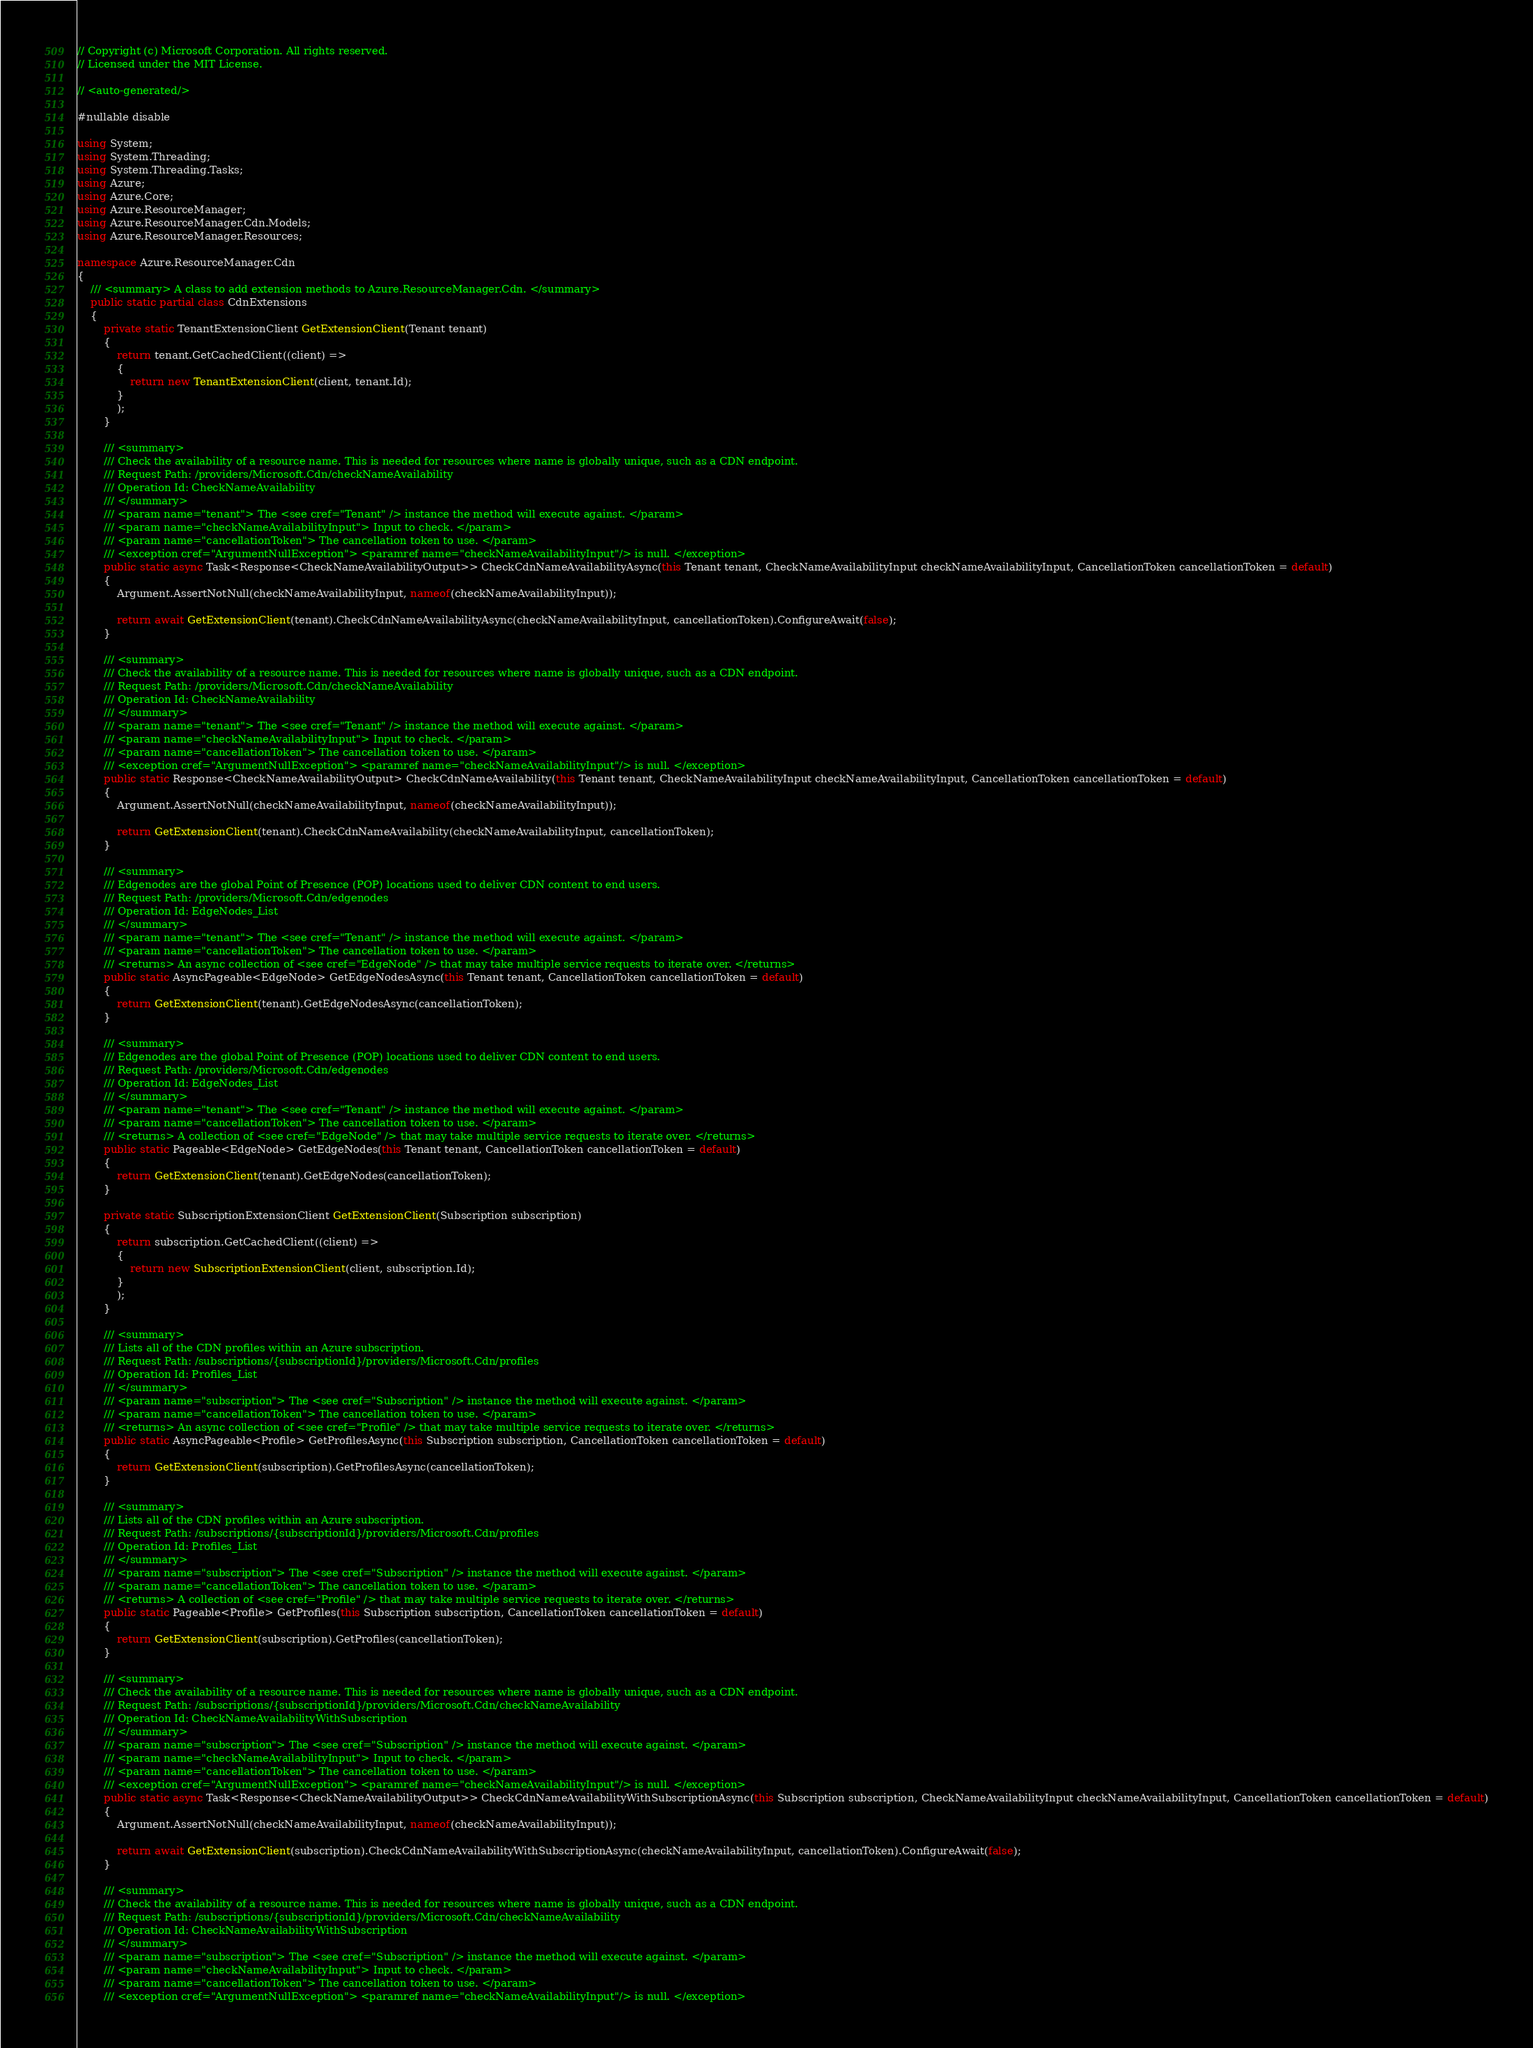<code> <loc_0><loc_0><loc_500><loc_500><_C#_>// Copyright (c) Microsoft Corporation. All rights reserved.
// Licensed under the MIT License.

// <auto-generated/>

#nullable disable

using System;
using System.Threading;
using System.Threading.Tasks;
using Azure;
using Azure.Core;
using Azure.ResourceManager;
using Azure.ResourceManager.Cdn.Models;
using Azure.ResourceManager.Resources;

namespace Azure.ResourceManager.Cdn
{
    /// <summary> A class to add extension methods to Azure.ResourceManager.Cdn. </summary>
    public static partial class CdnExtensions
    {
        private static TenantExtensionClient GetExtensionClient(Tenant tenant)
        {
            return tenant.GetCachedClient((client) =>
            {
                return new TenantExtensionClient(client, tenant.Id);
            }
            );
        }

        /// <summary>
        /// Check the availability of a resource name. This is needed for resources where name is globally unique, such as a CDN endpoint.
        /// Request Path: /providers/Microsoft.Cdn/checkNameAvailability
        /// Operation Id: CheckNameAvailability
        /// </summary>
        /// <param name="tenant"> The <see cref="Tenant" /> instance the method will execute against. </param>
        /// <param name="checkNameAvailabilityInput"> Input to check. </param>
        /// <param name="cancellationToken"> The cancellation token to use. </param>
        /// <exception cref="ArgumentNullException"> <paramref name="checkNameAvailabilityInput"/> is null. </exception>
        public static async Task<Response<CheckNameAvailabilityOutput>> CheckCdnNameAvailabilityAsync(this Tenant tenant, CheckNameAvailabilityInput checkNameAvailabilityInput, CancellationToken cancellationToken = default)
        {
            Argument.AssertNotNull(checkNameAvailabilityInput, nameof(checkNameAvailabilityInput));

            return await GetExtensionClient(tenant).CheckCdnNameAvailabilityAsync(checkNameAvailabilityInput, cancellationToken).ConfigureAwait(false);
        }

        /// <summary>
        /// Check the availability of a resource name. This is needed for resources where name is globally unique, such as a CDN endpoint.
        /// Request Path: /providers/Microsoft.Cdn/checkNameAvailability
        /// Operation Id: CheckNameAvailability
        /// </summary>
        /// <param name="tenant"> The <see cref="Tenant" /> instance the method will execute against. </param>
        /// <param name="checkNameAvailabilityInput"> Input to check. </param>
        /// <param name="cancellationToken"> The cancellation token to use. </param>
        /// <exception cref="ArgumentNullException"> <paramref name="checkNameAvailabilityInput"/> is null. </exception>
        public static Response<CheckNameAvailabilityOutput> CheckCdnNameAvailability(this Tenant tenant, CheckNameAvailabilityInput checkNameAvailabilityInput, CancellationToken cancellationToken = default)
        {
            Argument.AssertNotNull(checkNameAvailabilityInput, nameof(checkNameAvailabilityInput));

            return GetExtensionClient(tenant).CheckCdnNameAvailability(checkNameAvailabilityInput, cancellationToken);
        }

        /// <summary>
        /// Edgenodes are the global Point of Presence (POP) locations used to deliver CDN content to end users.
        /// Request Path: /providers/Microsoft.Cdn/edgenodes
        /// Operation Id: EdgeNodes_List
        /// </summary>
        /// <param name="tenant"> The <see cref="Tenant" /> instance the method will execute against. </param>
        /// <param name="cancellationToken"> The cancellation token to use. </param>
        /// <returns> An async collection of <see cref="EdgeNode" /> that may take multiple service requests to iterate over. </returns>
        public static AsyncPageable<EdgeNode> GetEdgeNodesAsync(this Tenant tenant, CancellationToken cancellationToken = default)
        {
            return GetExtensionClient(tenant).GetEdgeNodesAsync(cancellationToken);
        }

        /// <summary>
        /// Edgenodes are the global Point of Presence (POP) locations used to deliver CDN content to end users.
        /// Request Path: /providers/Microsoft.Cdn/edgenodes
        /// Operation Id: EdgeNodes_List
        /// </summary>
        /// <param name="tenant"> The <see cref="Tenant" /> instance the method will execute against. </param>
        /// <param name="cancellationToken"> The cancellation token to use. </param>
        /// <returns> A collection of <see cref="EdgeNode" /> that may take multiple service requests to iterate over. </returns>
        public static Pageable<EdgeNode> GetEdgeNodes(this Tenant tenant, CancellationToken cancellationToken = default)
        {
            return GetExtensionClient(tenant).GetEdgeNodes(cancellationToken);
        }

        private static SubscriptionExtensionClient GetExtensionClient(Subscription subscription)
        {
            return subscription.GetCachedClient((client) =>
            {
                return new SubscriptionExtensionClient(client, subscription.Id);
            }
            );
        }

        /// <summary>
        /// Lists all of the CDN profiles within an Azure subscription.
        /// Request Path: /subscriptions/{subscriptionId}/providers/Microsoft.Cdn/profiles
        /// Operation Id: Profiles_List
        /// </summary>
        /// <param name="subscription"> The <see cref="Subscription" /> instance the method will execute against. </param>
        /// <param name="cancellationToken"> The cancellation token to use. </param>
        /// <returns> An async collection of <see cref="Profile" /> that may take multiple service requests to iterate over. </returns>
        public static AsyncPageable<Profile> GetProfilesAsync(this Subscription subscription, CancellationToken cancellationToken = default)
        {
            return GetExtensionClient(subscription).GetProfilesAsync(cancellationToken);
        }

        /// <summary>
        /// Lists all of the CDN profiles within an Azure subscription.
        /// Request Path: /subscriptions/{subscriptionId}/providers/Microsoft.Cdn/profiles
        /// Operation Id: Profiles_List
        /// </summary>
        /// <param name="subscription"> The <see cref="Subscription" /> instance the method will execute against. </param>
        /// <param name="cancellationToken"> The cancellation token to use. </param>
        /// <returns> A collection of <see cref="Profile" /> that may take multiple service requests to iterate over. </returns>
        public static Pageable<Profile> GetProfiles(this Subscription subscription, CancellationToken cancellationToken = default)
        {
            return GetExtensionClient(subscription).GetProfiles(cancellationToken);
        }

        /// <summary>
        /// Check the availability of a resource name. This is needed for resources where name is globally unique, such as a CDN endpoint.
        /// Request Path: /subscriptions/{subscriptionId}/providers/Microsoft.Cdn/checkNameAvailability
        /// Operation Id: CheckNameAvailabilityWithSubscription
        /// </summary>
        /// <param name="subscription"> The <see cref="Subscription" /> instance the method will execute against. </param>
        /// <param name="checkNameAvailabilityInput"> Input to check. </param>
        /// <param name="cancellationToken"> The cancellation token to use. </param>
        /// <exception cref="ArgumentNullException"> <paramref name="checkNameAvailabilityInput"/> is null. </exception>
        public static async Task<Response<CheckNameAvailabilityOutput>> CheckCdnNameAvailabilityWithSubscriptionAsync(this Subscription subscription, CheckNameAvailabilityInput checkNameAvailabilityInput, CancellationToken cancellationToken = default)
        {
            Argument.AssertNotNull(checkNameAvailabilityInput, nameof(checkNameAvailabilityInput));

            return await GetExtensionClient(subscription).CheckCdnNameAvailabilityWithSubscriptionAsync(checkNameAvailabilityInput, cancellationToken).ConfigureAwait(false);
        }

        /// <summary>
        /// Check the availability of a resource name. This is needed for resources where name is globally unique, such as a CDN endpoint.
        /// Request Path: /subscriptions/{subscriptionId}/providers/Microsoft.Cdn/checkNameAvailability
        /// Operation Id: CheckNameAvailabilityWithSubscription
        /// </summary>
        /// <param name="subscription"> The <see cref="Subscription" /> instance the method will execute against. </param>
        /// <param name="checkNameAvailabilityInput"> Input to check. </param>
        /// <param name="cancellationToken"> The cancellation token to use. </param>
        /// <exception cref="ArgumentNullException"> <paramref name="checkNameAvailabilityInput"/> is null. </exception></code> 